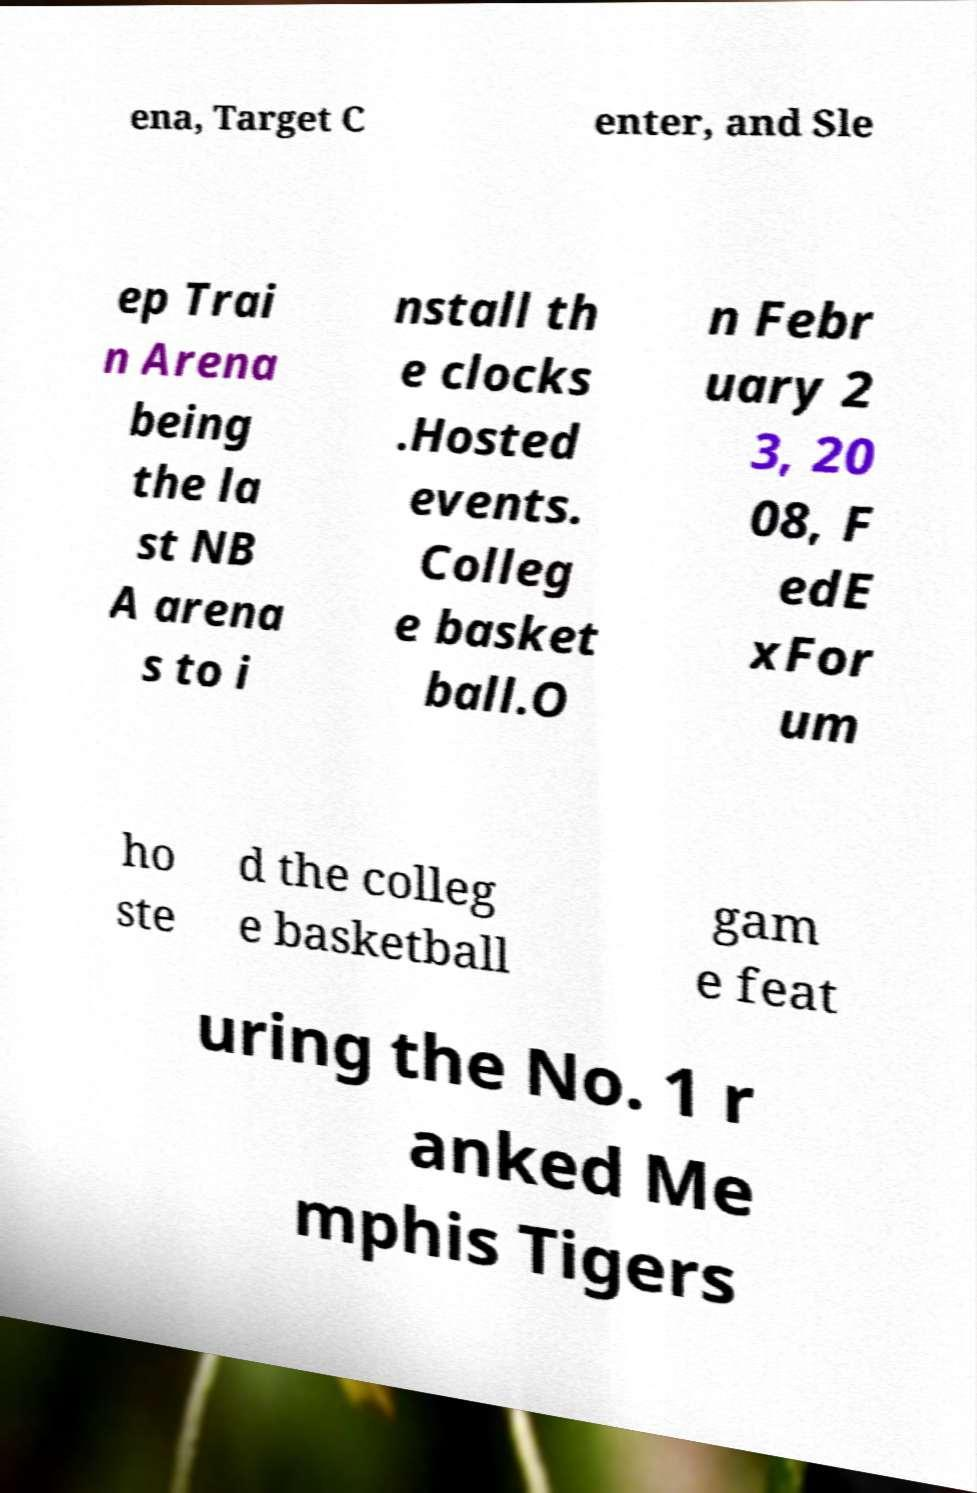Please read and relay the text visible in this image. What does it say? ena, Target C enter, and Sle ep Trai n Arena being the la st NB A arena s to i nstall th e clocks .Hosted events. Colleg e basket ball.O n Febr uary 2 3, 20 08, F edE xFor um ho ste d the colleg e basketball gam e feat uring the No. 1 r anked Me mphis Tigers 